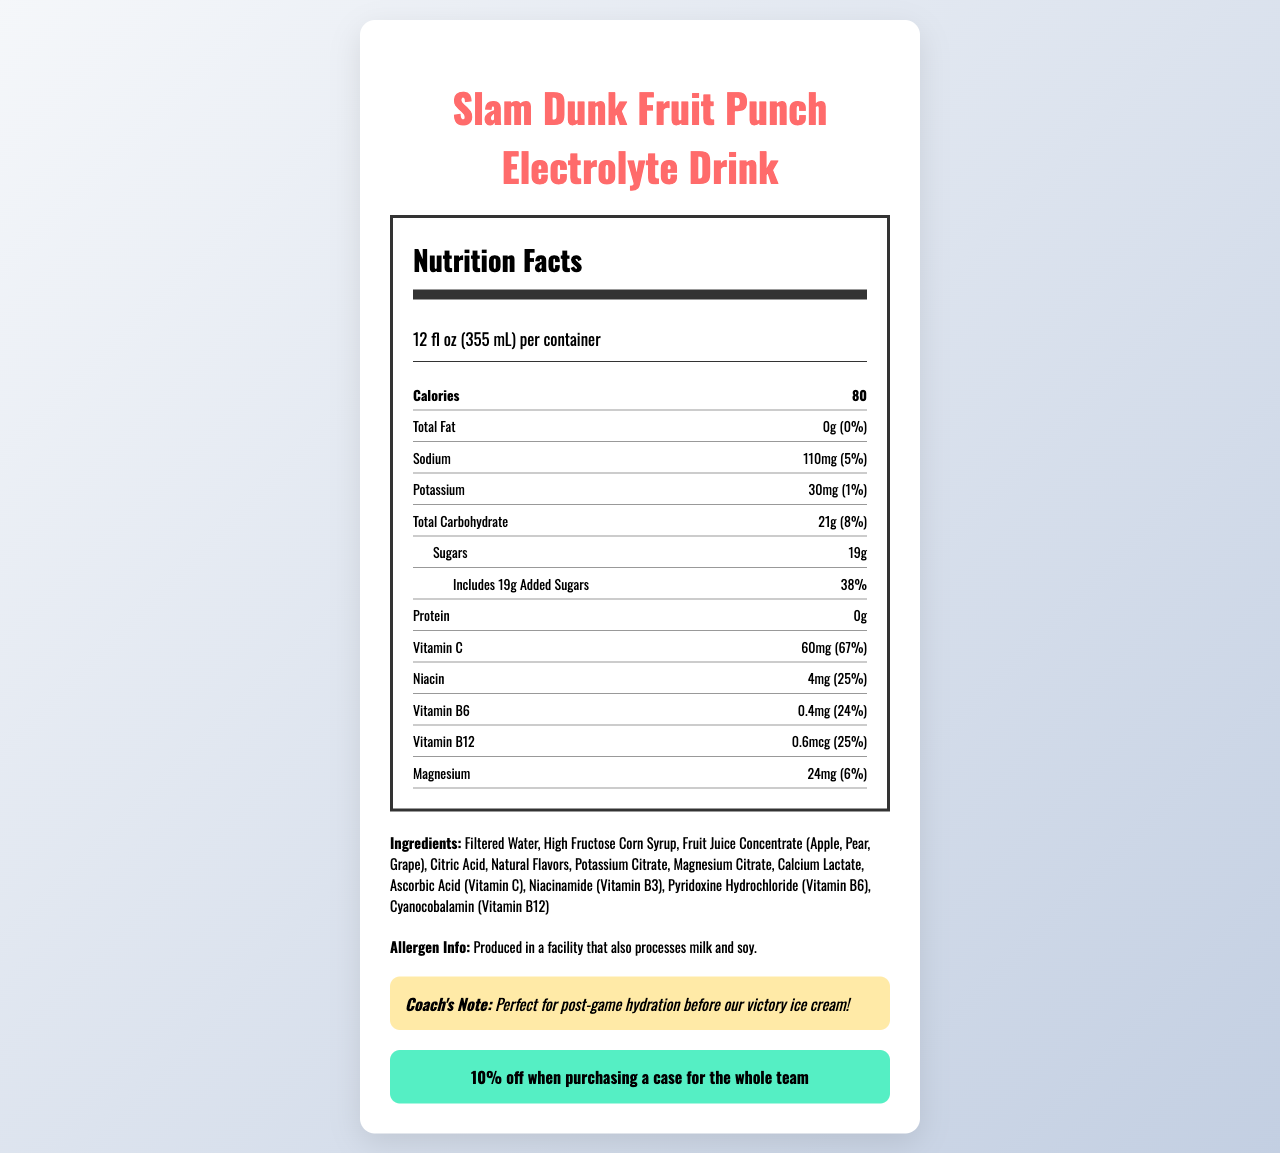what is the serving size of the Slam Dunk Fruit Punch Electrolyte Drink? The serving size is specified at the top of the Nutrition Facts section of the document.
Answer: 12 fl oz (355 mL) how many calories are in a single serving of the drink? The number of calories is listed immediately after the serving size.
Answer: 80 What is the percentage of daily value for sodium per serving? The daily value percentage for sodium is provided next to the amount of sodium in the document.
Answer: 5% how much total carbohydrate is in the drink? The total carbohydrate content is listed as 21 grams in the document.
Answer: 21g What is the coach's note for this drink? The coach's note is located at the bottom of the document, highlighted in a special section.
Answer: Perfect for post-game hydration before our victory ice cream! which vitamins and minerals are present in the drink? Please list them. These vitamins and minerals are listed under the vitamins and minerals section of the document.
Answer: Vitamin C, Niacin, Vitamin B6, Vitamin B12, Magnesium What proportion of the drink's total carbohydrate content consists of sugars? A. 50% B. 75% C. 90% D. 100% The drink contains 21g of total carbohydrates, out of which 19g are sugars. (19g/21g)*100 = ~90%
Answer: C What allergen information is provided for this drink? A. Contains milk B. Free from soy C. Contains traces of nuts D. Produced in a facility that processes milk and soy The allergen information stated in the document is "Produced in a facility that also processes milk and soy."
Answer: D How much protein does the drink contain? The protein content is listed as 0 grams in the document.
Answer: 0g Is this drink a good source of Vitamin C? The drink contains 60mg of Vitamin C, which is 67% of the daily value, indicating a good source of Vitamin C.
Answer: Yes How much potassium is in the drink? The potassium content is listed as 30 milligrams in the document.
Answer: 30mg Include this drink's ingredients list. The ingredients list is provided towards the bottom of the document under the "Ingredients" section.
Answer: Filtered Water, High Fructose Corn Syrup, Fruit Juice Concentrate (Apple, Pear, Grape), Citric Acid, Natural Flavors, Potassium Citrate, Magnesium Citrate, Calcium Lactate, Ascorbic Acid (Vitamin C), Niacinamide (Vitamin B3), Pyridoxine Hydrochloride (Vitamin B6), Cyanocobalamin (Vitamin B12) What is the team discount mentioned for the drink? The team discount is highlighted towards the end of the document in a special section.
Answer: 10% off when purchasing a case for the whole team Is there any information provided about fats in the drink? The document states that the total fat content is 0 grams, equating to 0% of the daily value.
Answer: Yes What are the main features of the Slam Dunk Fruit Punch Electrolyte Drink mentioned in the document? The main features include nutrient content, serving size, ingredients, allergen information, and additional notes and discounts provided by the coach.
Answer: The Slam Dunk Fruit Punch Electrolyte Drink is a fruit-flavored sports drink with added electrolytes. It contains 80 calories per serving, has 0 grams of fat, 19 grams of sugars, and includes vitamins and minerals such as Vitamin C, Niacin, Vitamin B6, Vitamin B12, and Magnesium. A coach's note and team discount are also provided. Would this drink be suitable for someone with a soy allergy? The only allergen information given is that it is produced in a facility that also processes milk and soy, which does not confirm whether the drink itself contains soy.
Answer: Cannot be determined 